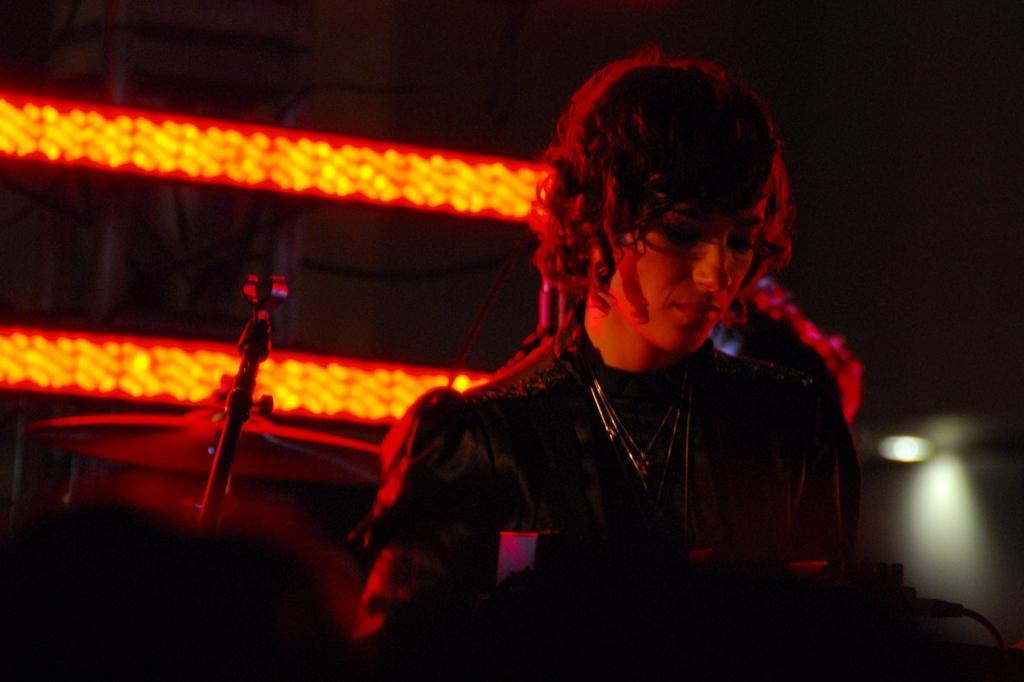Please provide a concise description of this image. In this image I can see the person. In the background I can see few musical instruments and I can also see few lights. 